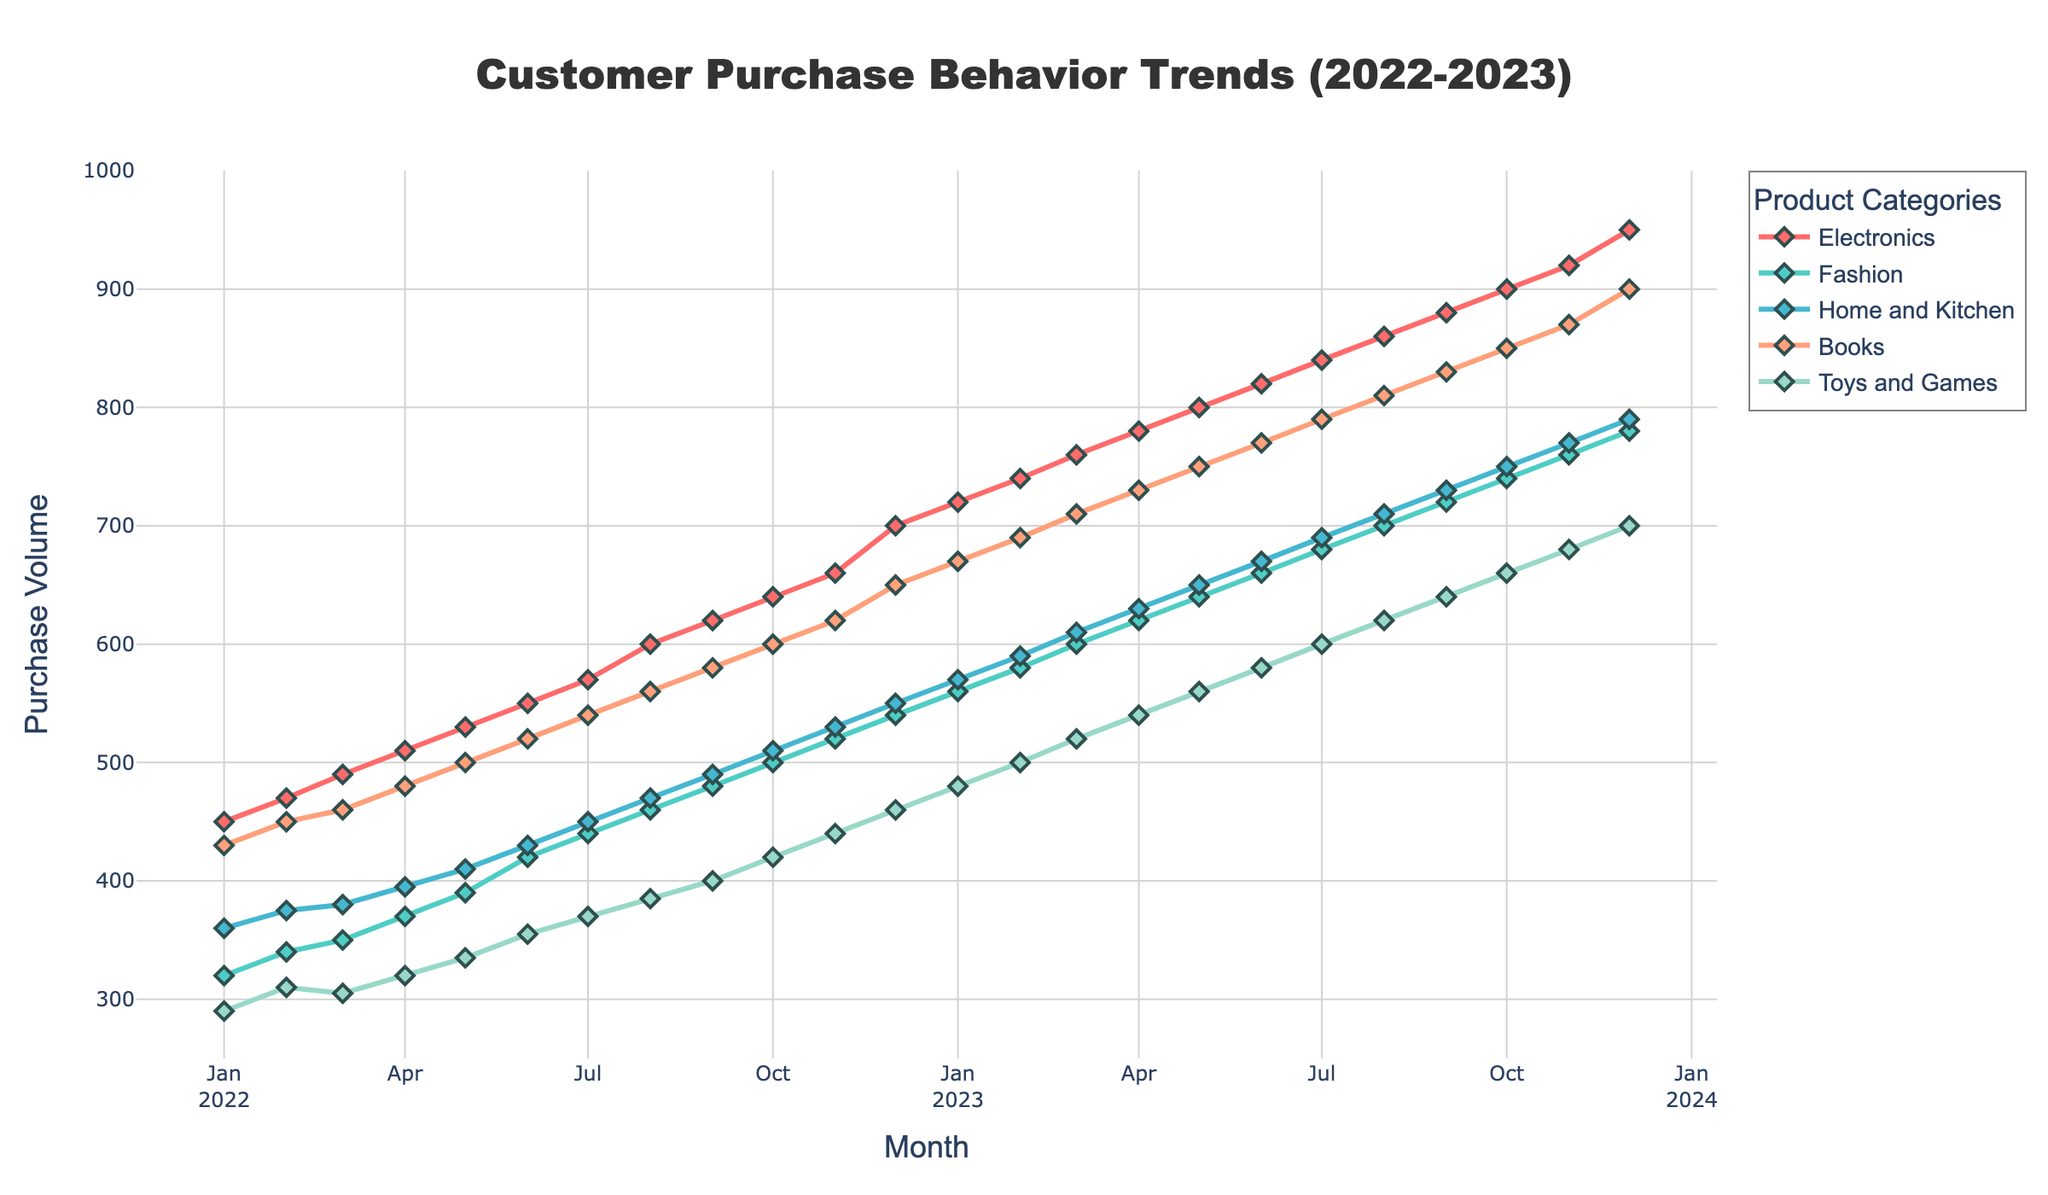Which category had the highest purchase volume in January 2023? Look at the data points for January 2023. The highest value among the categories for that month is Electronics with 720.
Answer: Electronics How does the purchase trend in the Electronics category compare between January 2022 and December 2023? Electronics started at 450 in January 2022 and increased steadily to 950 by December 2023. The category shows a consistent upward trend over the year.
Answer: Upward trend Which month in 2023 saw the highest purchase volume for Books? Examine the data for each month in 2023. December 2023 has the highest value for Books with 900.
Answer: December 2023 Did any category experience a consistent increase in purchase volume every month between 2022 and 2023? Review the purchase volumes for each category from month to month. Electronics consistently increased without any month showing a decrease.
Answer: Electronics What was the combined purchase volume for Fashion and Home and Kitchen in June 2023? Add the values for Fashion and Home and Kitchen in June 2023: 660 (Fashion) + 670 (Home and Kitchen) = 1330.
Answer: 1330 Which category experienced the smallest increase in purchase volume from January 2022 to December 2023? Calculate the difference for each category: Electronics (500), Fashion (460), Home and Kitchen (430), Books (470), Toys and Games (410). Toys and Games had the smallest increase.
Answer: Toys and Games How do the purchase trends for Fashion and Toys and Games compare over the year 2023? Evaluate the monthly data points for both categories in 2023. Both categories show an upward trend, but Fashion starts from 560 and goes to 780, while Toys and Games start at 480 and go to 700. Fashion has a higher overall increase.
Answer: Both upward, Fashion increases more What was the average monthly purchase volume for the Home and Kitchen category in 2023? Sum the Home and Kitchen values for each month in 2023 and divide by the number of months: (570 + 590 + 610 + 630 + 650 + 670 + 690 + 710 + 730 + 750 + 770 + 790)/12 = 682.5.
Answer: 682.5 In which month did Fashion first reach a purchase volume of 600? Observe the data for Fashion to find the month where the value first reaches 600. It happens in March 2023.
Answer: March 2023 Which category had the lowest purchase volume in all of 2022? Compare the lowest values for each category in 2022: Electronics (450), Fashion (320), Home and Kitchen (360), Books (430), Toys and Games (290). Toys and Games had the lowest value.
Answer: Toys and Games 